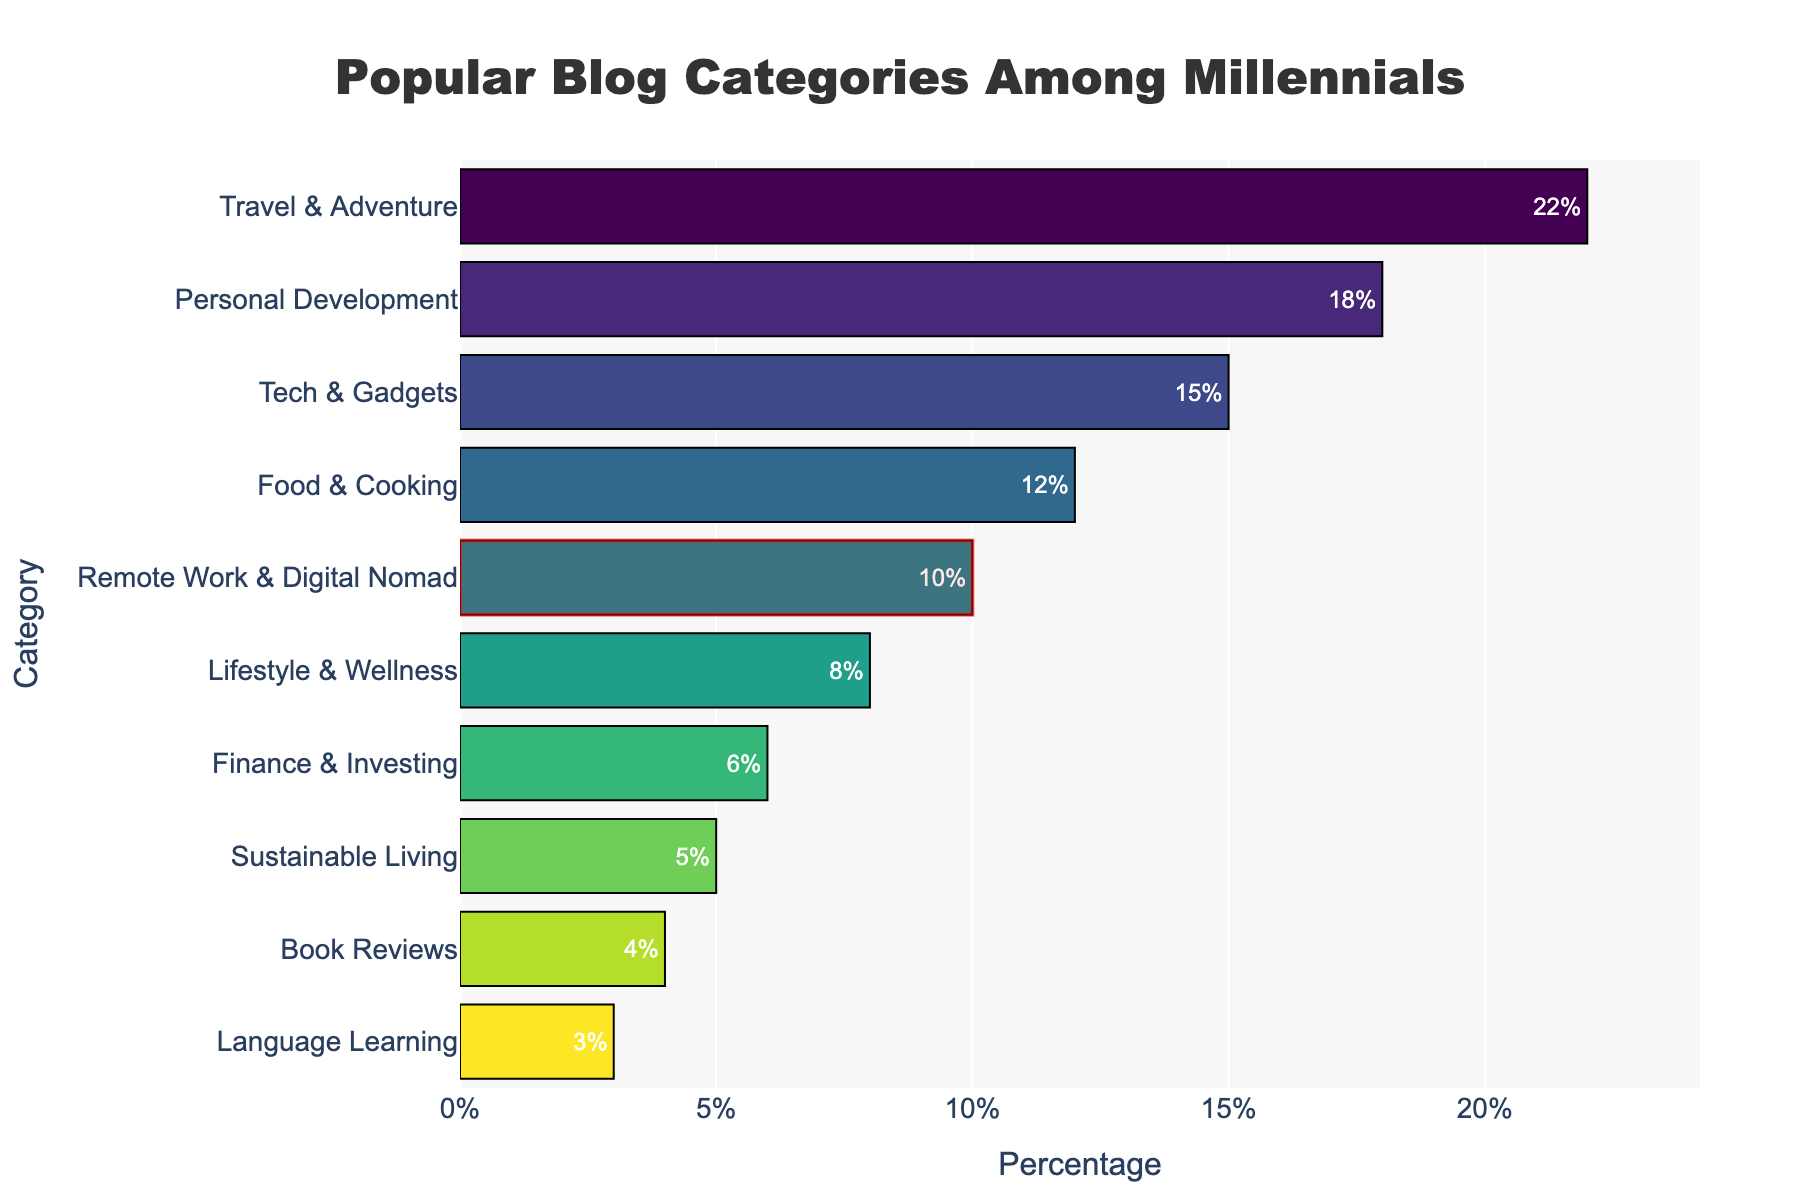what is the most popular blog category among millennials? The longest bar in the chart represents the blog category with the highest percentage, which is "Travel & Adventure" at 22%.
Answer: Travel & Adventure Which category has the lowest percentage and what is it? The shortest bar in the chart represents the blog category with the lowest percentage, which is "Language Learning" at 3%.
Answer: Language Learning Compare the percentage of "Tech & Gadgets" and "Food & Cooking". Which one is higher and by how much? "Tech & Gadgets" has a percentage of 15% and "Food & Cooking" has 12%. The difference is 15% - 12% = 3%. "Tech & Gadgets" is higher by 3%.
Answer: Tech & Gadgets by 3% What is the combined percentage of "Personal Development" and "Finance & Investing"? The percentage for "Personal Development" is 18% and for "Finance & Investing" is 6%. The combined percentage is 18% + 6% = 24%.
Answer: 24% How many categories have a percentage less than 10%? The categories with percentages less than 10% are "Lifestyle & Wellness" (8%), "Finance & Investing" (6%), "Sustainable Living" (5%), "Book Reviews" (4%), and "Language Learning" (3%). There are 5 such categories.
Answer: 5 What is the percentage for the category highlighted by a rectangle? The rectangular highlight indicates the "Remote Work & Digital Nomad" category, which has a percentage of 10%.
Answer: 10% Arrange the top three most popular categories in descending order of their percentage. The top three categories by percentage are "Travel & Adventure" (22%), "Personal Development" (18%), and "Tech & Gadgets" (15%).
Answer: Travel & Adventure, Personal Development, Tech & Gadgets Compare the combined percentage of "Sustainable Living" and "Book Reviews" to "Remote Work & Digital Nomad" category. Which one is higher? "Sustainable Living" has 5% and "Book Reviews" has 4%, so their combined percentage is 5% + 4% = 9%. "Remote Work & Digital Nomad" has 10%, which is higher.
Answer: Remote Work & Digital Nomad What is the average percentage of the bottom five categories? The bottom five categories are "Finance & Investing" (6%), "Sustainable Living" (5%), "Book Reviews" (4%), "Language Learning" (3%), and "Lifestyle & Wellness" (8%). Their average percentage is (6 + 5 + 4 + 3 + 8) / 5 = 5.2%.
Answer: 5.2% What is the difference in percentage between the most and least popular categories? The most popular category is "Travel & Adventure" with 22%, and the least popular is "Language Learning" with 3%, so the difference is 22% - 3% = 19%.
Answer: 19% 